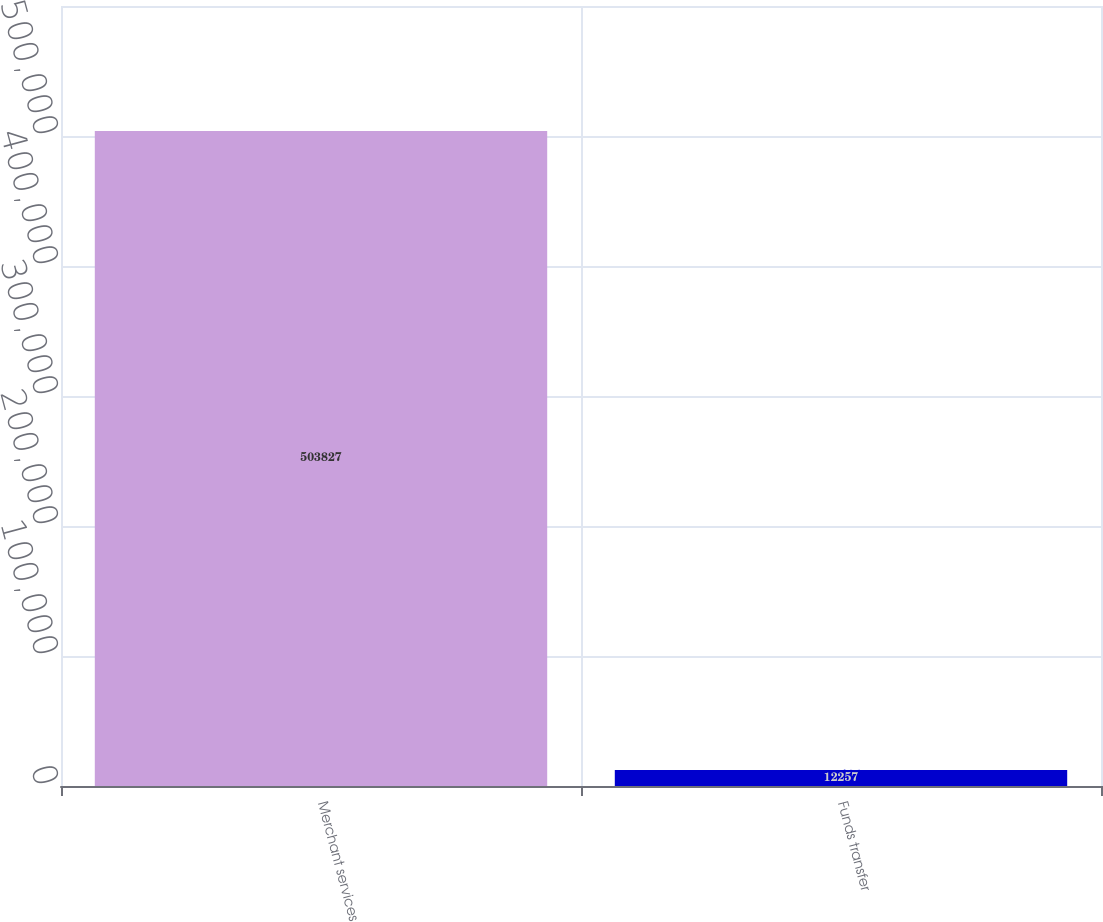<chart> <loc_0><loc_0><loc_500><loc_500><bar_chart><fcel>Merchant services<fcel>Funds transfer<nl><fcel>503827<fcel>12257<nl></chart> 